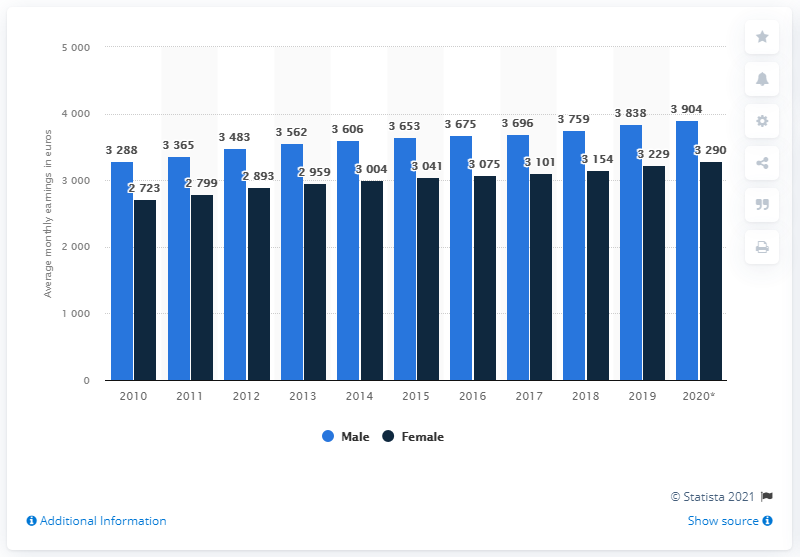Indicate a few pertinent items in this graphic. The average monthly earnings of males in 2014 was approximately 3606. The difference between the maximum and minimum female earnings is 567. 